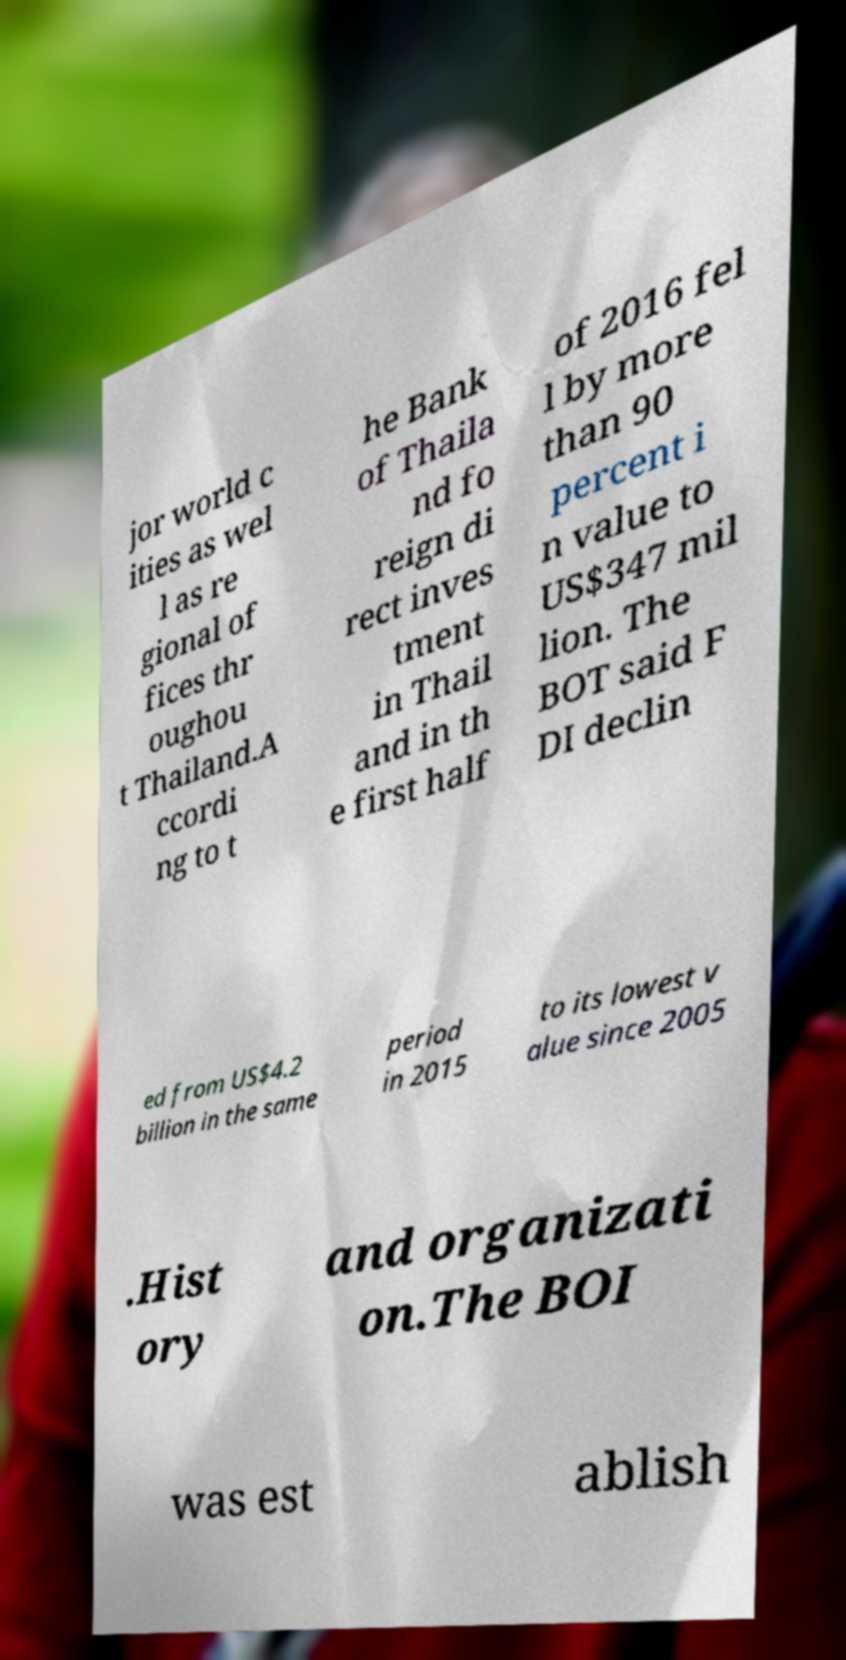I need the written content from this picture converted into text. Can you do that? jor world c ities as wel l as re gional of fices thr oughou t Thailand.A ccordi ng to t he Bank of Thaila nd fo reign di rect inves tment in Thail and in th e first half of 2016 fel l by more than 90 percent i n value to US$347 mil lion. The BOT said F DI declin ed from US$4.2 billion in the same period in 2015 to its lowest v alue since 2005 .Hist ory and organizati on.The BOI was est ablish 